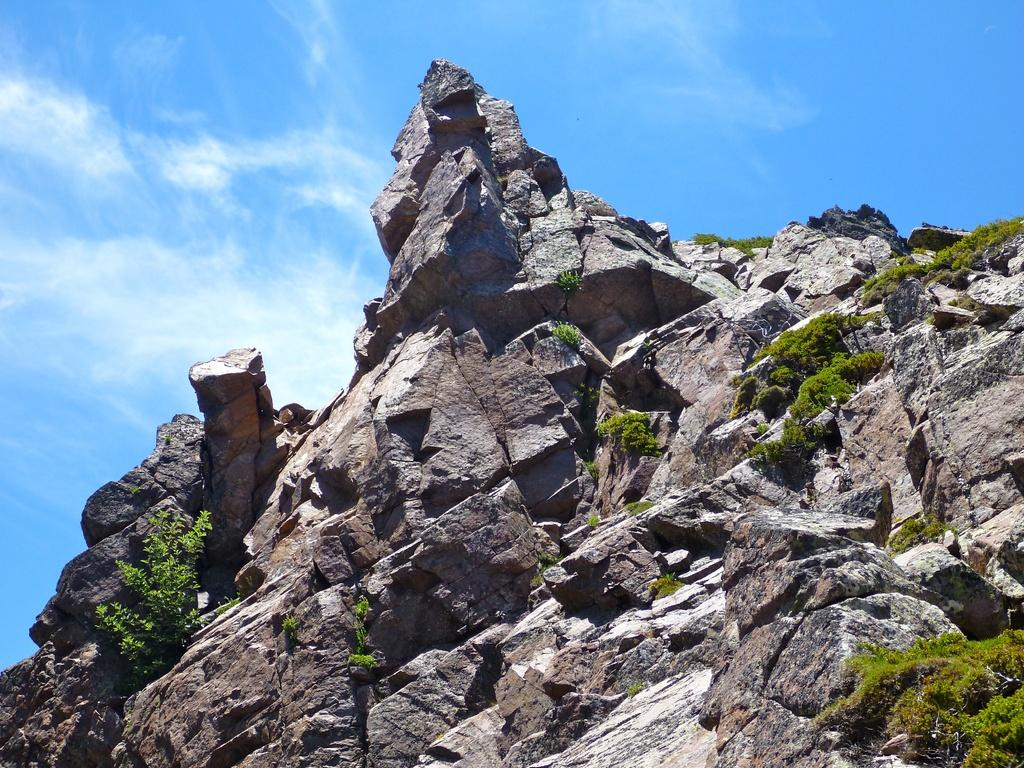What is the main subject in the center of the image? There is a rock with grass in the center of the image. What can be seen in the background of the image? The sky is visible at the top of the image. How much anger is expressed by the rock in the image? There is no expression of anger by the rock in the image, as rocks are inanimate objects and do not have emotions. 